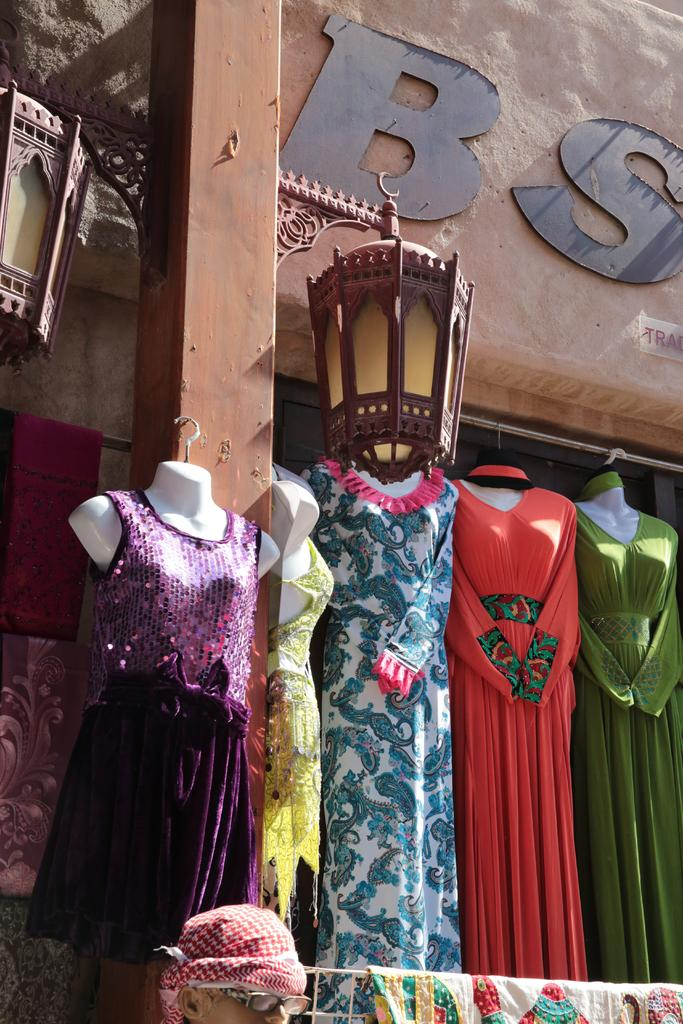What type of structure is visible in the image? There is a building in the image. What objects are present that provide light? There are lamps in the image. What can be seen hanging in the image? Clothes are hanging in the image. Can you describe the person in the image? There is a person at the bottom of the image. What type of crack can be seen on the edge of the scene in the image? There is no crack or edge present in the image; it is a picture of a building, lamps, hanging clothes, and a person. 